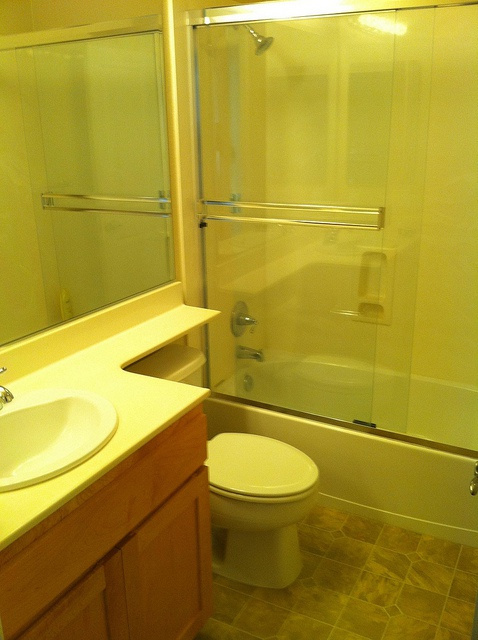Describe the objects in this image and their specific colors. I can see toilet in olive, khaki, and black tones and sink in olive, khaki, and gold tones in this image. 